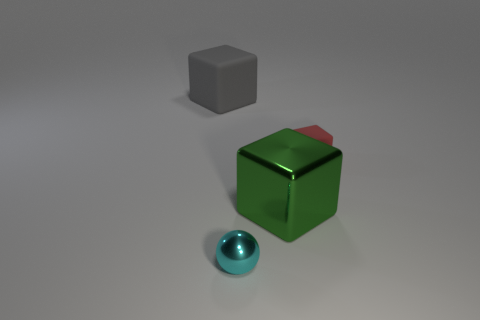Subtract all red rubber cubes. How many cubes are left? 2 Add 3 small metal cylinders. How many objects exist? 7 Subtract 1 blocks. How many blocks are left? 2 Subtract all blocks. How many objects are left? 1 Subtract all gray cubes. Subtract all red balls. How many cubes are left? 2 Subtract all small gray spheres. Subtract all big shiny objects. How many objects are left? 3 Add 4 small blocks. How many small blocks are left? 5 Add 1 small gray blocks. How many small gray blocks exist? 1 Subtract all green cubes. How many cubes are left? 2 Subtract 0 green spheres. How many objects are left? 4 